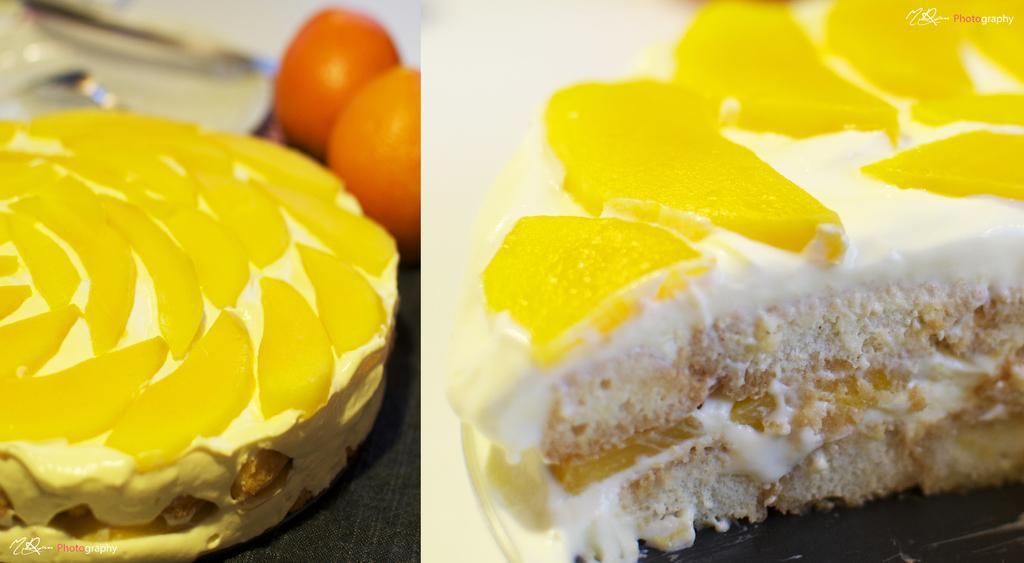In one or two sentences, can you explain what this image depicts? This image is a collage of two images. In this image there is a pastry with a few fruit slices on it and there are two oranges on the table. 